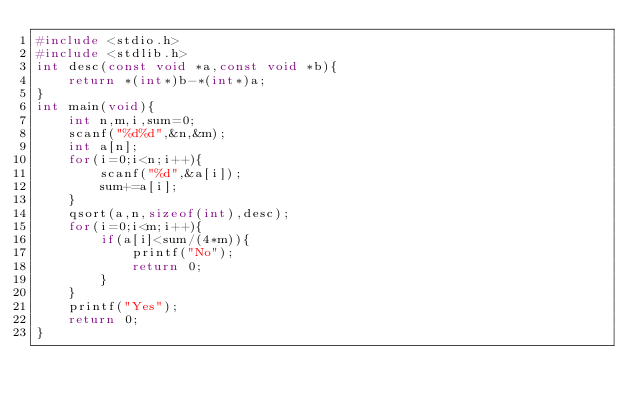Convert code to text. <code><loc_0><loc_0><loc_500><loc_500><_C_>#include <stdio.h>
#include <stdlib.h>
int desc(const void *a,const void *b){
    return *(int*)b-*(int*)a;
}
int main(void){
    int n,m,i,sum=0;
    scanf("%d%d",&n,&m);
    int a[n];
    for(i=0;i<n;i++){
        scanf("%d",&a[i]);
        sum+=a[i];
    }
    qsort(a,n,sizeof(int),desc);
    for(i=0;i<m;i++){
        if(a[i]<sum/(4*m)){
            printf("No");
            return 0;
        }
    }
    printf("Yes");
    return 0;
}
</code> 